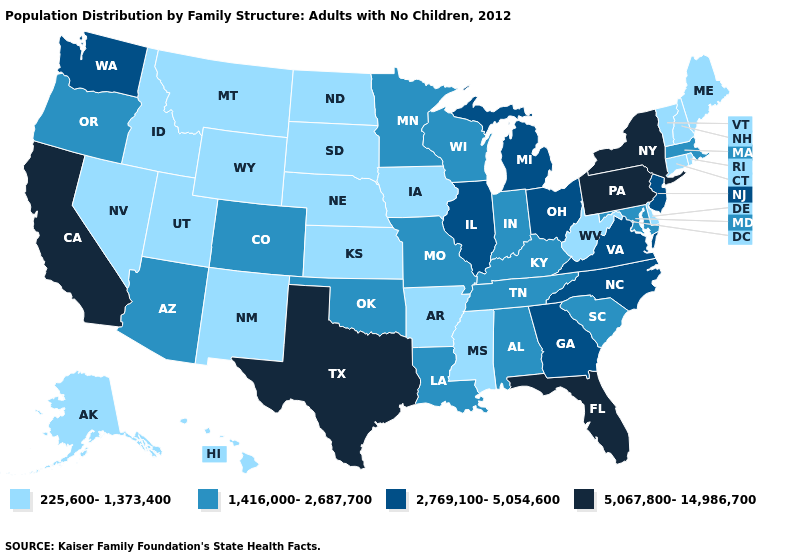Which states have the lowest value in the West?
Concise answer only. Alaska, Hawaii, Idaho, Montana, Nevada, New Mexico, Utah, Wyoming. Does California have a higher value than Arkansas?
Write a very short answer. Yes. Which states have the lowest value in the USA?
Short answer required. Alaska, Arkansas, Connecticut, Delaware, Hawaii, Idaho, Iowa, Kansas, Maine, Mississippi, Montana, Nebraska, Nevada, New Hampshire, New Mexico, North Dakota, Rhode Island, South Dakota, Utah, Vermont, West Virginia, Wyoming. Among the states that border Illinois , which have the highest value?
Concise answer only. Indiana, Kentucky, Missouri, Wisconsin. What is the highest value in the USA?
Be succinct. 5,067,800-14,986,700. Name the states that have a value in the range 225,600-1,373,400?
Write a very short answer. Alaska, Arkansas, Connecticut, Delaware, Hawaii, Idaho, Iowa, Kansas, Maine, Mississippi, Montana, Nebraska, Nevada, New Hampshire, New Mexico, North Dakota, Rhode Island, South Dakota, Utah, Vermont, West Virginia, Wyoming. Among the states that border Washington , which have the lowest value?
Give a very brief answer. Idaho. What is the lowest value in states that border South Dakota?
Answer briefly. 225,600-1,373,400. Which states hav the highest value in the South?
Quick response, please. Florida, Texas. What is the value of Kentucky?
Write a very short answer. 1,416,000-2,687,700. Among the states that border Kansas , which have the lowest value?
Answer briefly. Nebraska. How many symbols are there in the legend?
Give a very brief answer. 4. Does Texas have the highest value in the USA?
Quick response, please. Yes. Among the states that border Virginia , which have the lowest value?
Answer briefly. West Virginia. What is the highest value in the MidWest ?
Give a very brief answer. 2,769,100-5,054,600. 